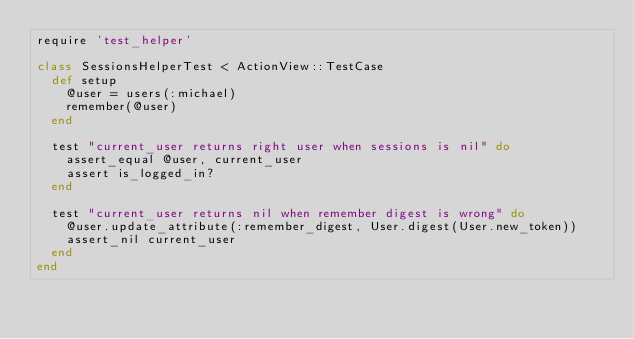<code> <loc_0><loc_0><loc_500><loc_500><_Ruby_>require 'test_helper'

class SessionsHelperTest < ActionView::TestCase
  def setup
    @user = users(:michael)
    remember(@user)
  end

  test "current_user returns right user when sessions is nil" do
    assert_equal @user, current_user
    assert is_logged_in?
  end

  test "current_user returns nil when remember digest is wrong" do
    @user.update_attribute(:remember_digest, User.digest(User.new_token))
    assert_nil current_user
  end
end
</code> 